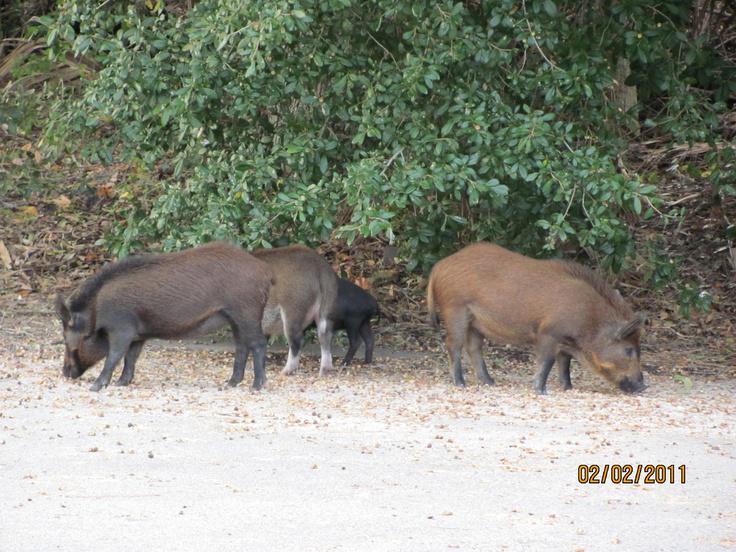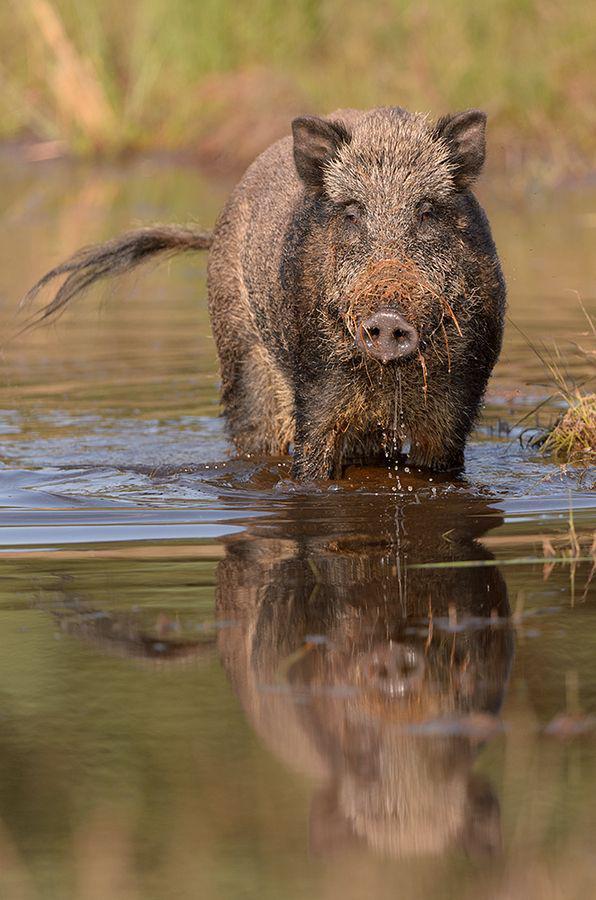The first image is the image on the left, the second image is the image on the right. Given the left and right images, does the statement "One image shows a wild pig wading in brown water" hold true? Answer yes or no. Yes. The first image is the image on the left, the second image is the image on the right. Considering the images on both sides, is "An image contains a single boar wading through water." valid? Answer yes or no. Yes. 